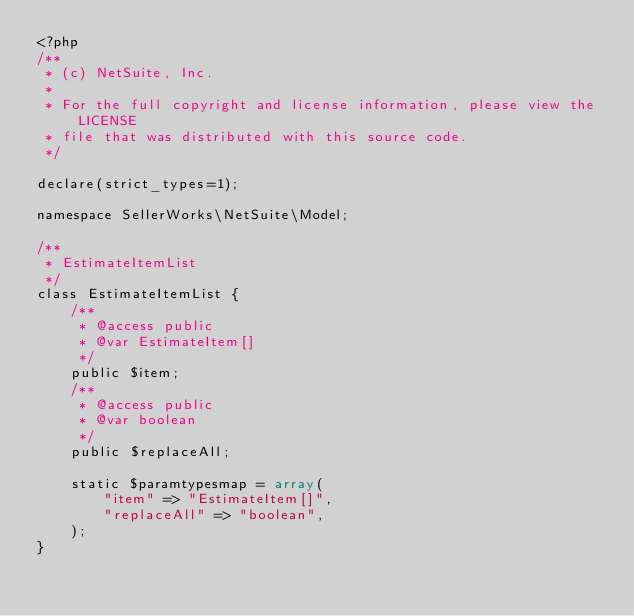<code> <loc_0><loc_0><loc_500><loc_500><_PHP_><?php
/**
 * (c) NetSuite, Inc.
 *
 * For the full copyright and license information, please view the LICENSE
 * file that was distributed with this source code.
 */

declare(strict_types=1);

namespace SellerWorks\NetSuite\Model;

/**
 * EstimateItemList
 */
class EstimateItemList {
	/**
	 * @access public
	 * @var EstimateItem[]
	 */
	public $item;
	/**
	 * @access public
	 * @var boolean
	 */
	public $replaceAll;

	static $paramtypesmap = array(
		"item" => "EstimateItem[]",
		"replaceAll" => "boolean",
	);
}
</code> 